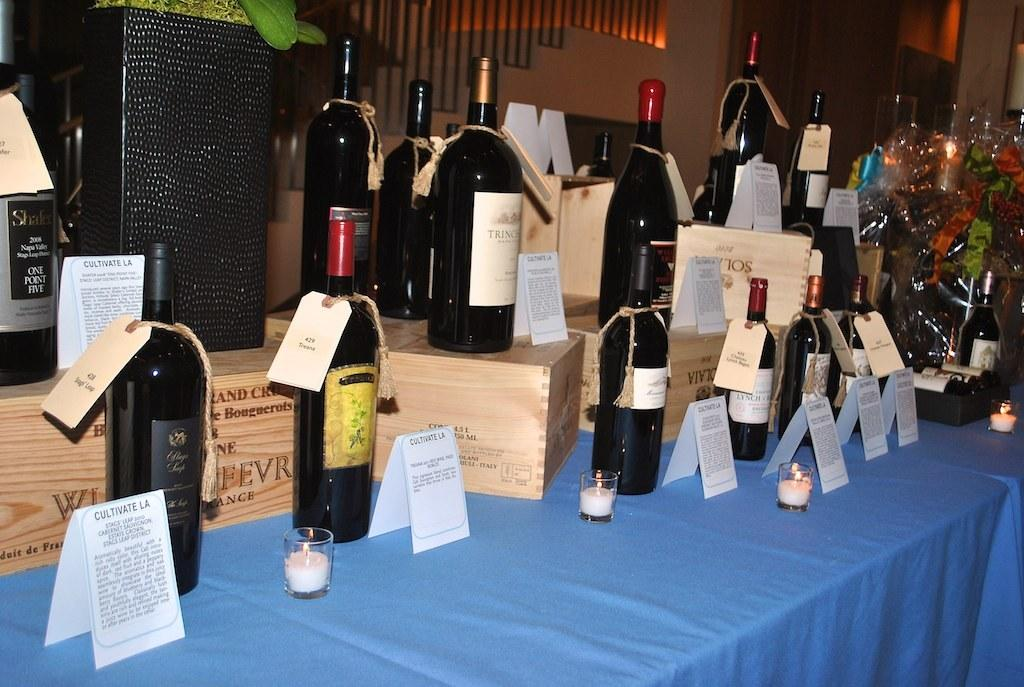<image>
Share a concise interpretation of the image provided. Several bottles of wine have signs in front of them that say cultivate la at the top. 